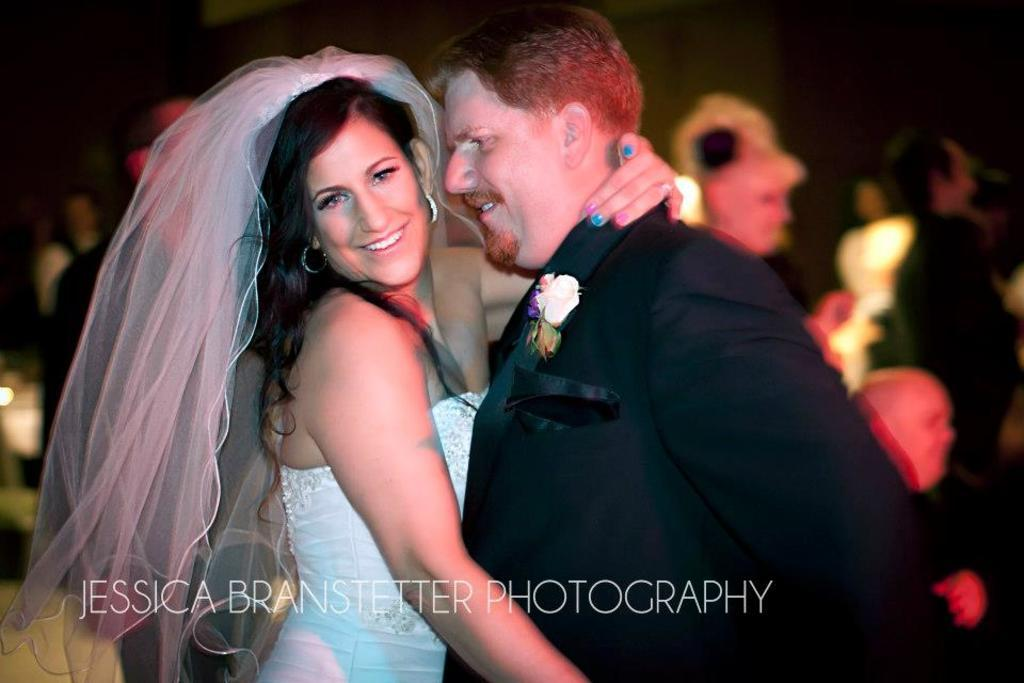Who is present in the image? There is a man and a woman in the image. What are the man and woman doing in the image? The man and woman are smiling in the image. What can be found at the bottom of the image? There is some text at the bottom of the image. How many people are visible in the image? There are people visible in the image. Can you describe the background of the image? The background of the image is blurry. What flavor of sleet is falling in the image? There is no sleet present in the image, and therefore no flavor can be determined. 